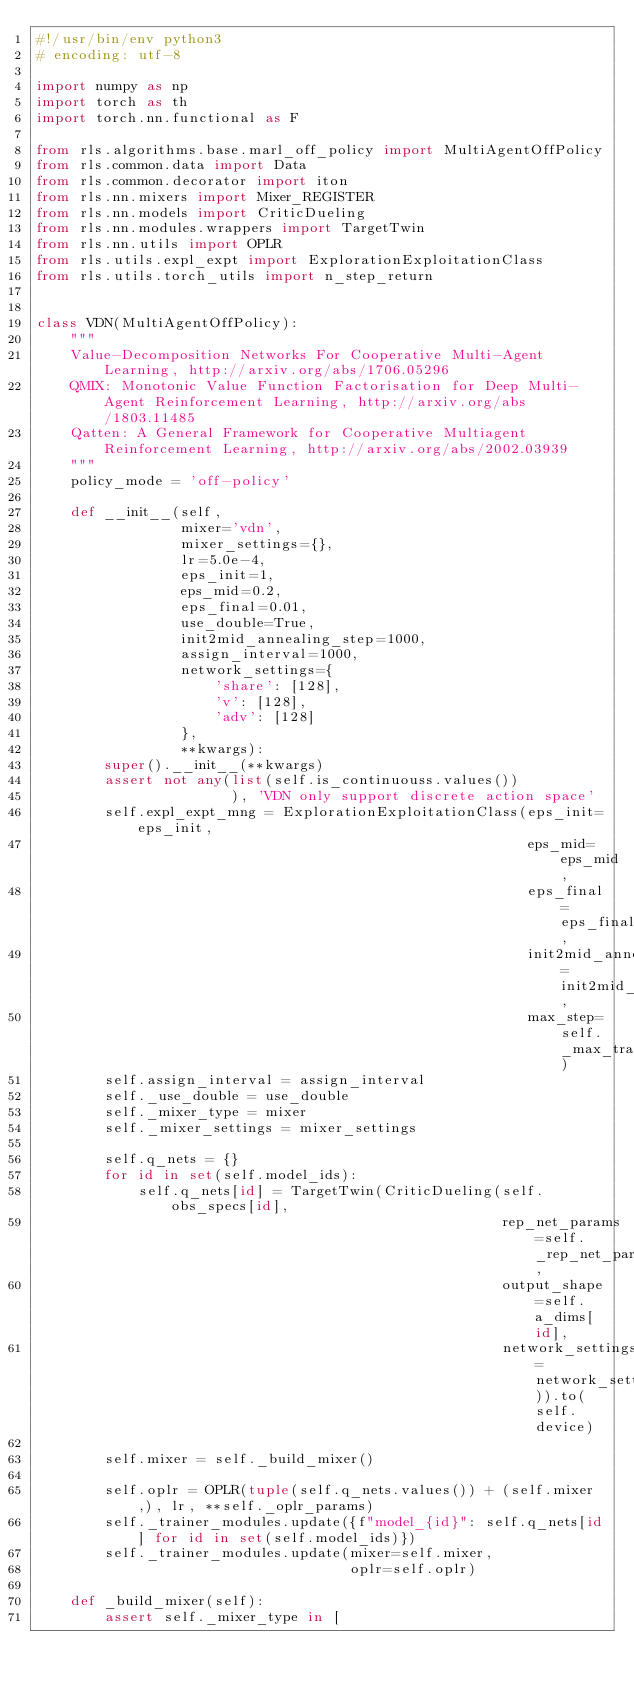Convert code to text. <code><loc_0><loc_0><loc_500><loc_500><_Python_>#!/usr/bin/env python3
# encoding: utf-8

import numpy as np
import torch as th
import torch.nn.functional as F

from rls.algorithms.base.marl_off_policy import MultiAgentOffPolicy
from rls.common.data import Data
from rls.common.decorator import iton
from rls.nn.mixers import Mixer_REGISTER
from rls.nn.models import CriticDueling
from rls.nn.modules.wrappers import TargetTwin
from rls.nn.utils import OPLR
from rls.utils.expl_expt import ExplorationExploitationClass
from rls.utils.torch_utils import n_step_return


class VDN(MultiAgentOffPolicy):
    """
    Value-Decomposition Networks For Cooperative Multi-Agent Learning, http://arxiv.org/abs/1706.05296
    QMIX: Monotonic Value Function Factorisation for Deep Multi-Agent Reinforcement Learning, http://arxiv.org/abs/1803.11485
    Qatten: A General Framework for Cooperative Multiagent Reinforcement Learning, http://arxiv.org/abs/2002.03939
    """
    policy_mode = 'off-policy'

    def __init__(self,
                 mixer='vdn',
                 mixer_settings={},
                 lr=5.0e-4,
                 eps_init=1,
                 eps_mid=0.2,
                 eps_final=0.01,
                 use_double=True,
                 init2mid_annealing_step=1000,
                 assign_interval=1000,
                 network_settings={
                     'share': [128],
                     'v': [128],
                     'adv': [128]
                 },
                 **kwargs):
        super().__init__(**kwargs)
        assert not any(list(self.is_continuouss.values())
                       ), 'VDN only support discrete action space'
        self.expl_expt_mng = ExplorationExploitationClass(eps_init=eps_init,
                                                          eps_mid=eps_mid,
                                                          eps_final=eps_final,
                                                          init2mid_annealing_step=init2mid_annealing_step,
                                                          max_step=self._max_train_step)
        self.assign_interval = assign_interval
        self._use_double = use_double
        self._mixer_type = mixer
        self._mixer_settings = mixer_settings

        self.q_nets = {}
        for id in set(self.model_ids):
            self.q_nets[id] = TargetTwin(CriticDueling(self.obs_specs[id],
                                                       rep_net_params=self._rep_net_params,
                                                       output_shape=self.a_dims[id],
                                                       network_settings=network_settings)).to(self.device)

        self.mixer = self._build_mixer()

        self.oplr = OPLR(tuple(self.q_nets.values()) + (self.mixer,), lr, **self._oplr_params)
        self._trainer_modules.update({f"model_{id}": self.q_nets[id] for id in set(self.model_ids)})
        self._trainer_modules.update(mixer=self.mixer,
                                     oplr=self.oplr)

    def _build_mixer(self):
        assert self._mixer_type in [</code> 